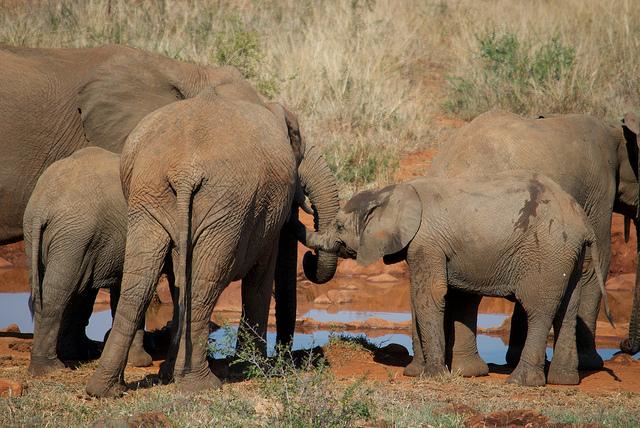Do these elephants live on a plain?
Keep it brief. Yes. Are the animals likely in captivity?
Write a very short answer. No. What color is the animals?
Answer briefly. Gray. What is the color of the grass?
Be succinct. Green. How many elephants are standing in water?
Answer briefly. 0. How many elephants in this picture?
Be succinct. 5. Are the elephants entering their pen?
Keep it brief. No. How many elephants?
Answer briefly. 5. Are the animals in their natural habitat?
Give a very brief answer. Yes. How many elephants are in the picture?
Keep it brief. 5. What have the elephants gathered around?
Write a very short answer. Water. How many full grown elephants are visible?
Keep it brief. 3. What is the middle elephant doing?
Give a very brief answer. Playing. 